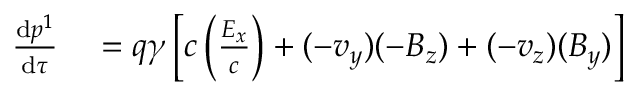Convert formula to latex. <formula><loc_0><loc_0><loc_500><loc_500>\begin{array} { r l } { { \frac { d p ^ { 1 } } { d \tau } } } & = q \gamma \left [ c \left ( { \frac { E _ { x } } { c } } \right ) + ( - v _ { y } ) ( - B _ { z } ) + ( - v _ { z } ) ( B _ { y } ) \right ] } \end{array}</formula> 